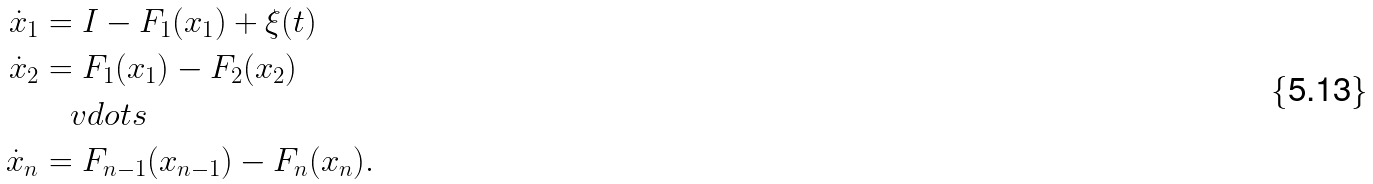<formula> <loc_0><loc_0><loc_500><loc_500>\dot { x } _ { 1 } & = I - F _ { 1 } ( x _ { 1 } ) + \xi ( t ) \\ \dot { x } _ { 2 } & = F _ { 1 } ( x _ { 1 } ) - F _ { 2 } ( x _ { 2 } ) \\ & \quad v d o t s \\ \dot { x } _ { n } & = F _ { n - 1 } ( x _ { n - 1 } ) - F _ { n } ( x _ { n } ) .</formula> 